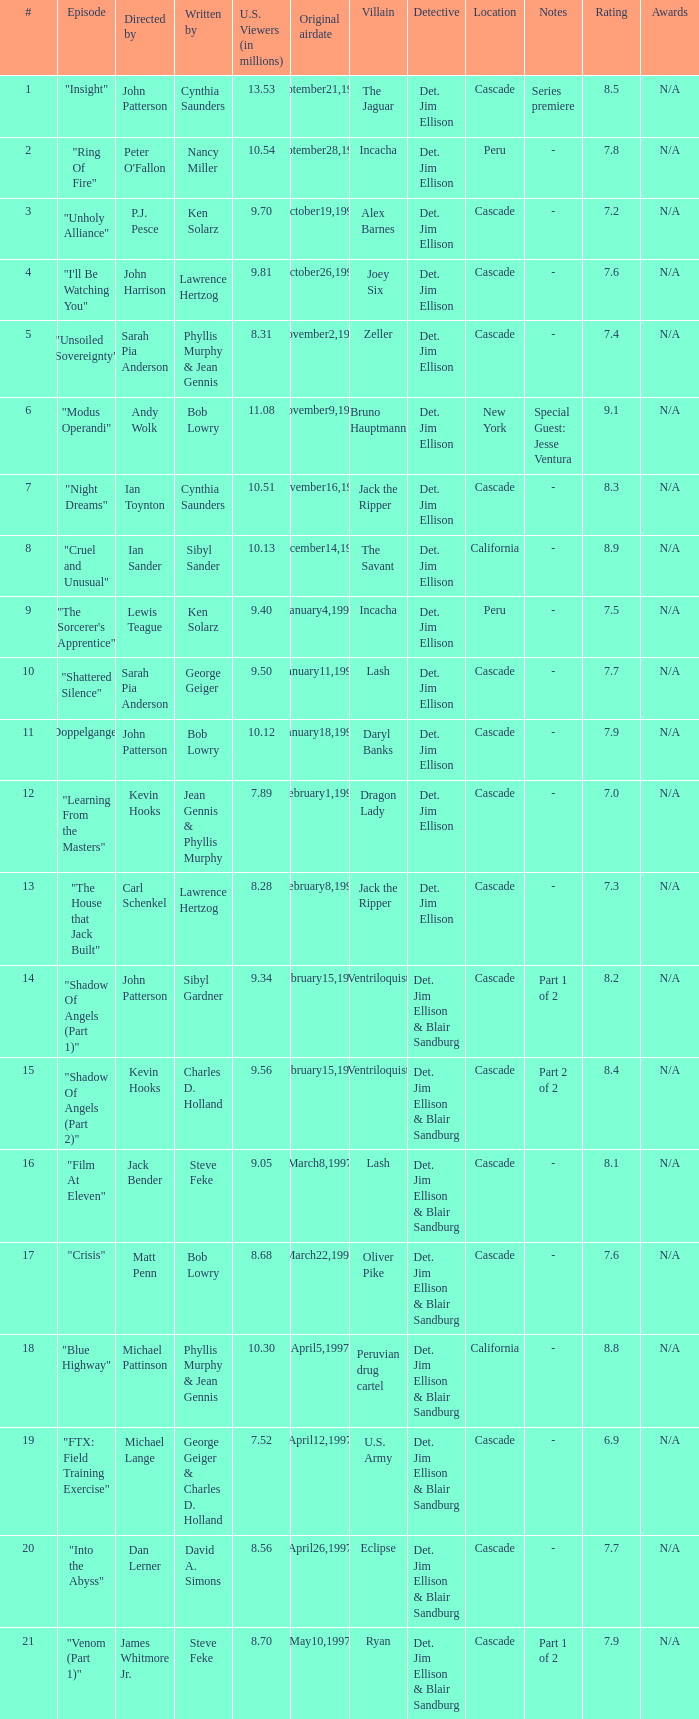What are the titles of episodes numbered 19? "FTX: Field Training Exercise". 